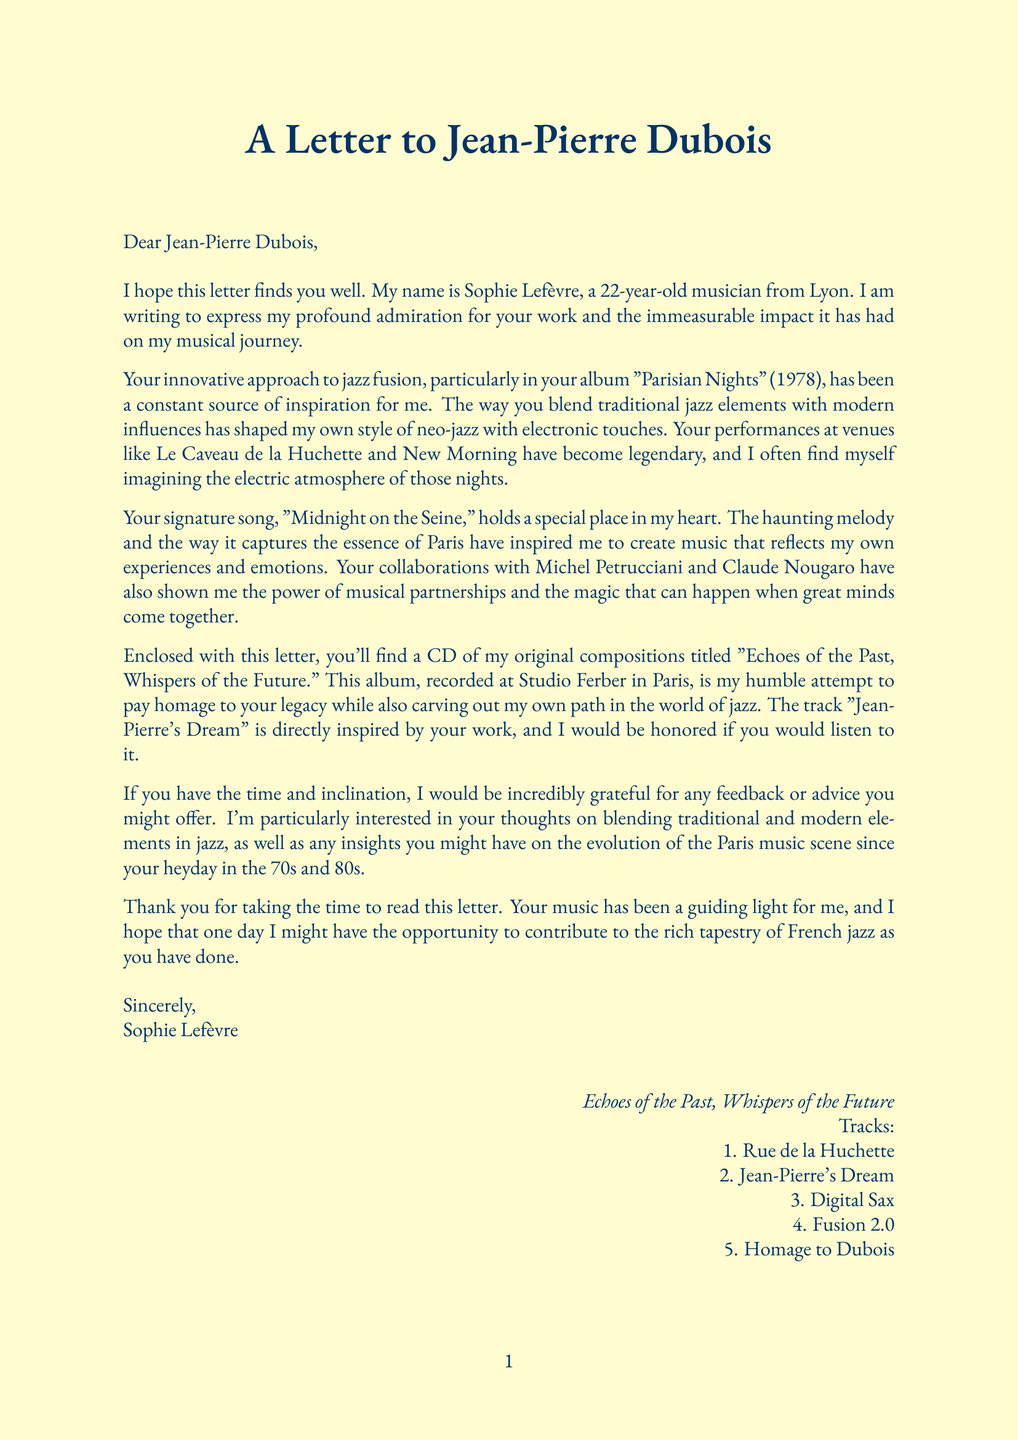What is the name of the young musician? The young musician who wrote the letter introduces herself as Sophie Lefèvre.
Answer: Sophie Lefèvre What is the title of the enclosed CD? The CD that Sophie Lefèvre is sending is titled "Echoes of the Past, Whispers of the Future."
Answer: Echoes of the Past, Whispers of the Future Which instrument does Sophie Lefèvre play? The letter states that Sophie plays the piano and synthesizer.
Answer: Piano and synthesizer What specific song by Jean-Pierre is mentioned? The letter refers to Jean-Pierre's signature song, which is significant to Sophie.
Answer: Midnight on the Seine What venue is referenced as a legendary performance location? The young musician mentions Le Caveau de la Huchette as one of the legendary venues.
Answer: Le Caveau de la Huchette Who produced Sophie Lefèvre's CD? The document specifies that the producer of the CD is Marc Dupont.
Answer: Marc Dupont What musical style does Sophie claim to be influenced by? Sophie describes her musical style as neo-jazz with electronic influences.
Answer: Neo-jazz with electronic influences What track is inspired directly by Jean-Pierre’s work? Sophie mentions that the track "Jean-Pierre's Dream" is inspired by Jean-Pierre's work.
Answer: Jean-Pierre's Dream What advice is Sophie seeking from Jean-Pierre? Sophie is particularly interested in advice about blending traditional and modern elements in jazz.
Answer: Blending traditional and modern elements 